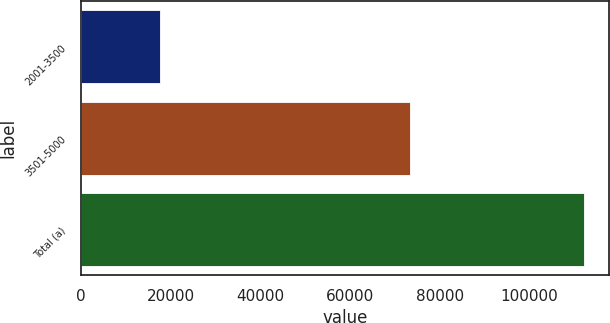Convert chart to OTSL. <chart><loc_0><loc_0><loc_500><loc_500><bar_chart><fcel>2001-3500<fcel>3501-5000<fcel>Total (a)<nl><fcel>17750<fcel>73298<fcel>112184<nl></chart> 